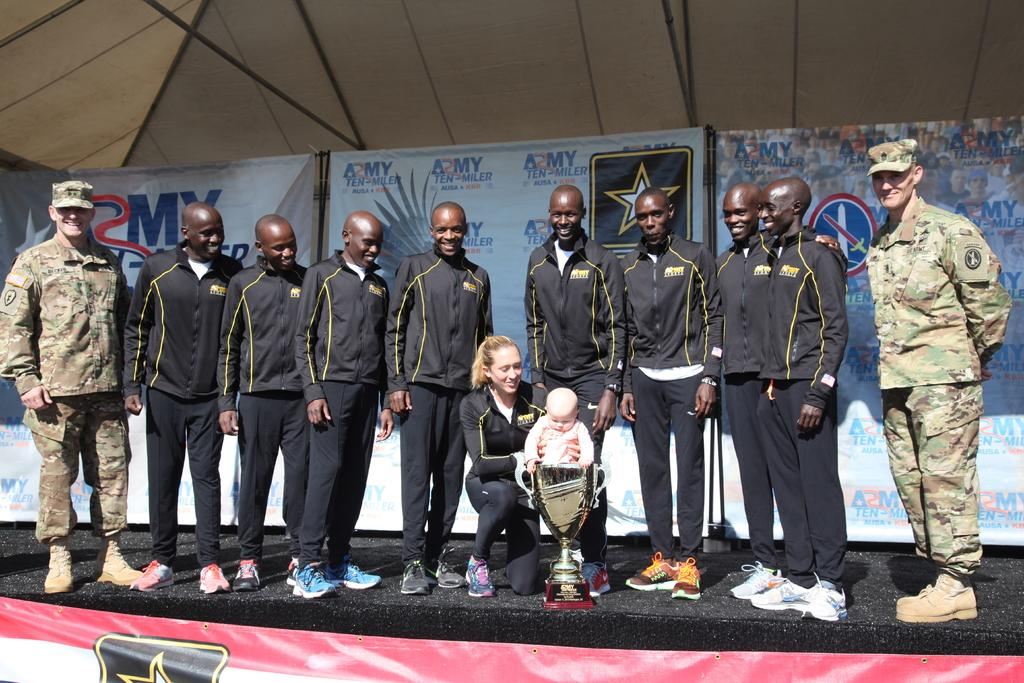What are the people on the dais doing? The men are standing, and the woman is sitting on the dais. What is the woman holding in her hands? The woman is holding a baby in her hands. What can be seen in the background of the image? There is a shed, an advertisement, and a trophy visible in the background. How many matches are being played in the image? There is no indication of a match or matches being played in the image. What size is the trophy in the image? The size of the trophy cannot be determined from the image alone. 